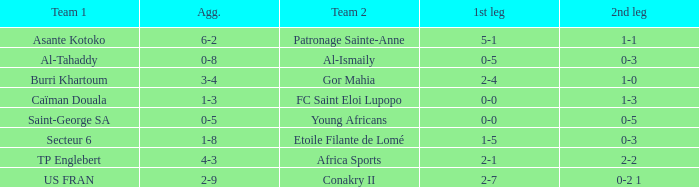What was the result of the second leg game between patronage sainte-anne and asante kotoko? 1-1. 